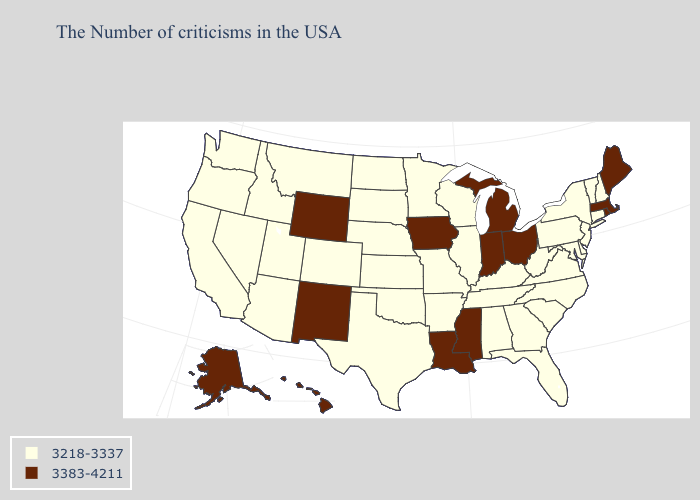What is the highest value in the USA?
Be succinct. 3383-4211. Name the states that have a value in the range 3218-3337?
Write a very short answer. New Hampshire, Vermont, Connecticut, New York, New Jersey, Delaware, Maryland, Pennsylvania, Virginia, North Carolina, South Carolina, West Virginia, Florida, Georgia, Kentucky, Alabama, Tennessee, Wisconsin, Illinois, Missouri, Arkansas, Minnesota, Kansas, Nebraska, Oklahoma, Texas, South Dakota, North Dakota, Colorado, Utah, Montana, Arizona, Idaho, Nevada, California, Washington, Oregon. Does Pennsylvania have the highest value in the USA?
Concise answer only. No. Which states have the lowest value in the South?
Short answer required. Delaware, Maryland, Virginia, North Carolina, South Carolina, West Virginia, Florida, Georgia, Kentucky, Alabama, Tennessee, Arkansas, Oklahoma, Texas. What is the value of Kentucky?
Quick response, please. 3218-3337. Does Maryland have a lower value than Alabama?
Short answer required. No. What is the value of Ohio?
Keep it brief. 3383-4211. Name the states that have a value in the range 3218-3337?
Keep it brief. New Hampshire, Vermont, Connecticut, New York, New Jersey, Delaware, Maryland, Pennsylvania, Virginia, North Carolina, South Carolina, West Virginia, Florida, Georgia, Kentucky, Alabama, Tennessee, Wisconsin, Illinois, Missouri, Arkansas, Minnesota, Kansas, Nebraska, Oklahoma, Texas, South Dakota, North Dakota, Colorado, Utah, Montana, Arizona, Idaho, Nevada, California, Washington, Oregon. Does Maryland have the same value as Connecticut?
Write a very short answer. Yes. Is the legend a continuous bar?
Write a very short answer. No. What is the value of Montana?
Be succinct. 3218-3337. What is the lowest value in states that border Virginia?
Give a very brief answer. 3218-3337. What is the lowest value in the Northeast?
Concise answer only. 3218-3337. Name the states that have a value in the range 3218-3337?
Be succinct. New Hampshire, Vermont, Connecticut, New York, New Jersey, Delaware, Maryland, Pennsylvania, Virginia, North Carolina, South Carolina, West Virginia, Florida, Georgia, Kentucky, Alabama, Tennessee, Wisconsin, Illinois, Missouri, Arkansas, Minnesota, Kansas, Nebraska, Oklahoma, Texas, South Dakota, North Dakota, Colorado, Utah, Montana, Arizona, Idaho, Nevada, California, Washington, Oregon. What is the highest value in the MidWest ?
Give a very brief answer. 3383-4211. 